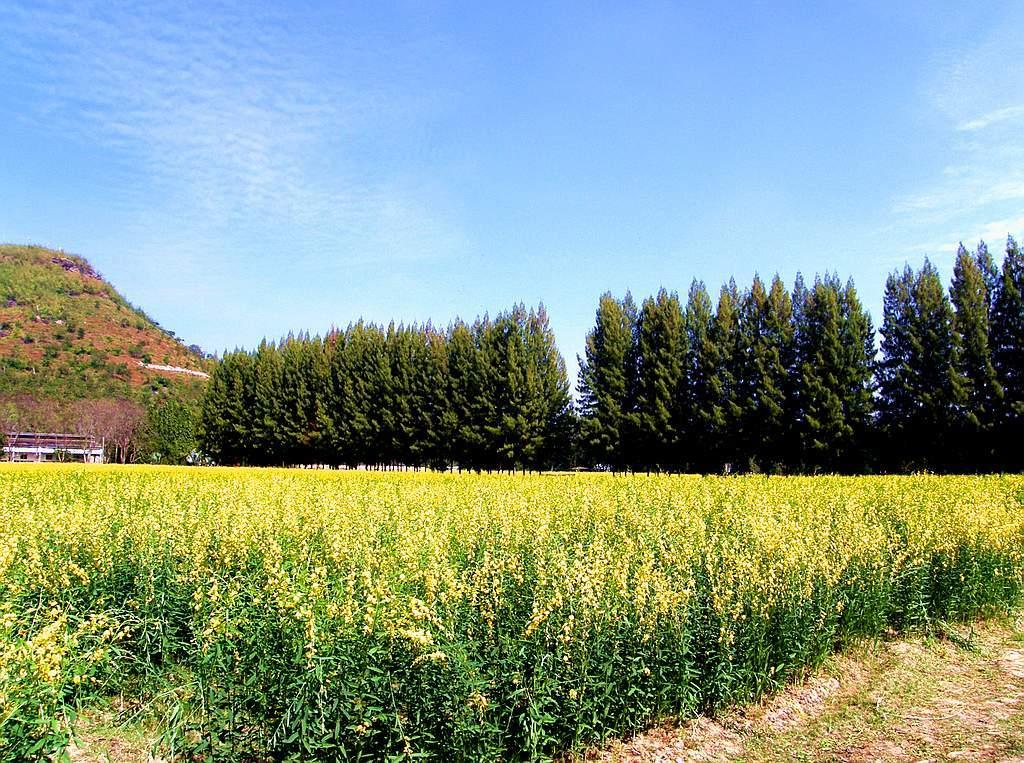What type of vegetation is on the ground in the image? There are plants on the ground in the image. What can be seen in the background of the image? There are trees and a mountain visible in the background of the image. Are there any plants on the mountain? Yes, there are plants on the mountain. What is visible at the top of the image? The sky is visible at the top of the image. Can you see a horn on any of the plants in the image? There is no horn present on any of the plants in the image. How does the mountain stretch across the image? The mountain does not stretch across the image; it is a stationary object in the background. 